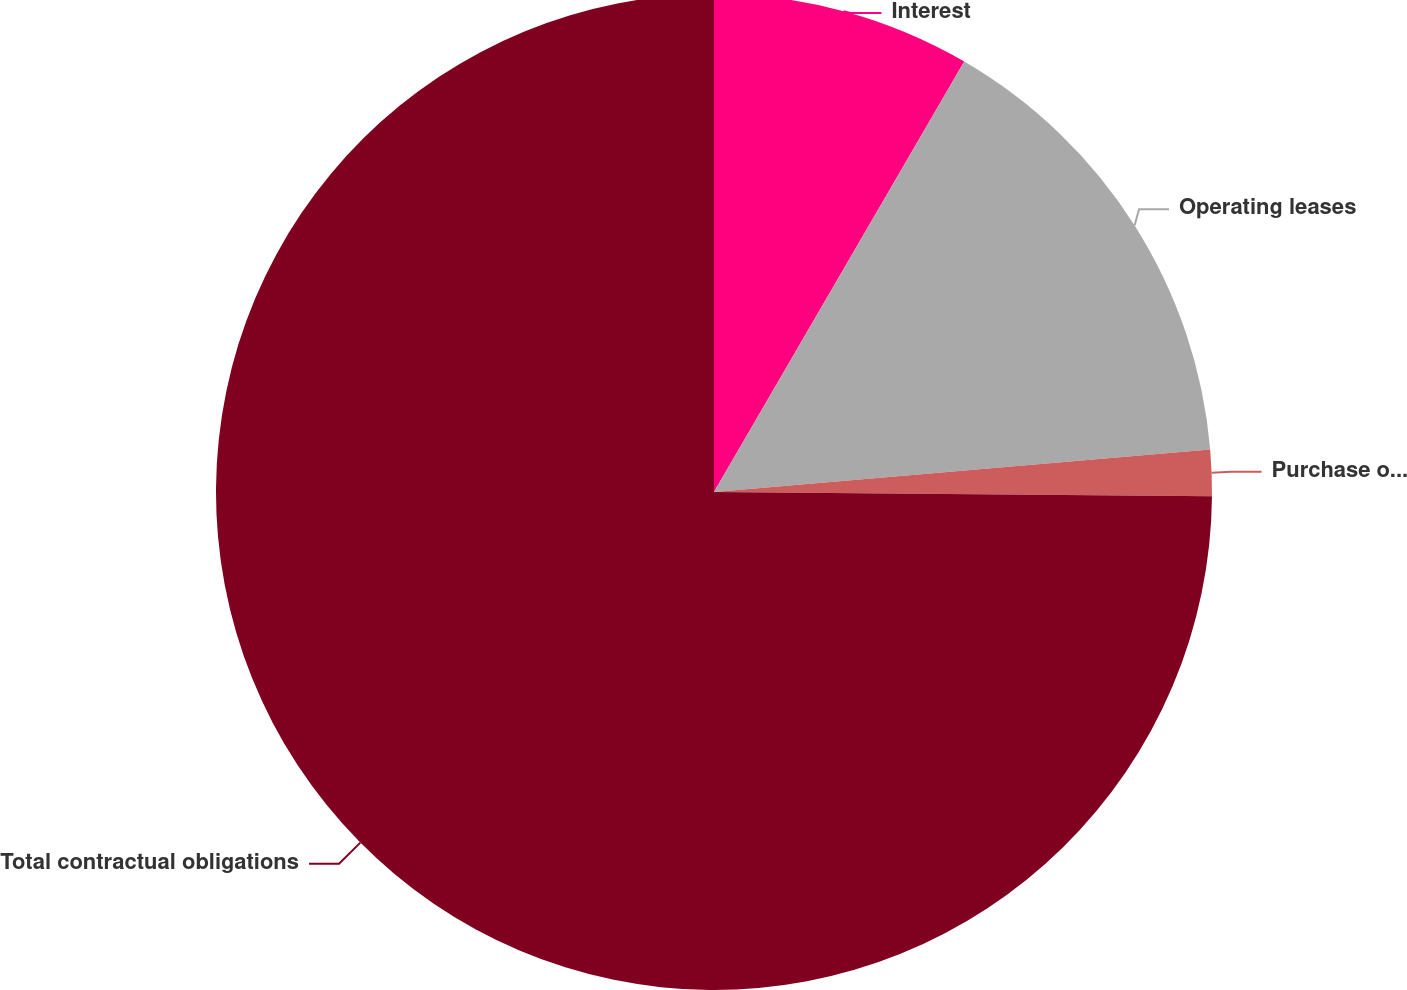Convert chart to OTSL. <chart><loc_0><loc_0><loc_500><loc_500><pie_chart><fcel>Interest<fcel>Operating leases<fcel>Purchase obligations<fcel>Total contractual obligations<nl><fcel>8.38%<fcel>15.26%<fcel>1.5%<fcel>74.87%<nl></chart> 